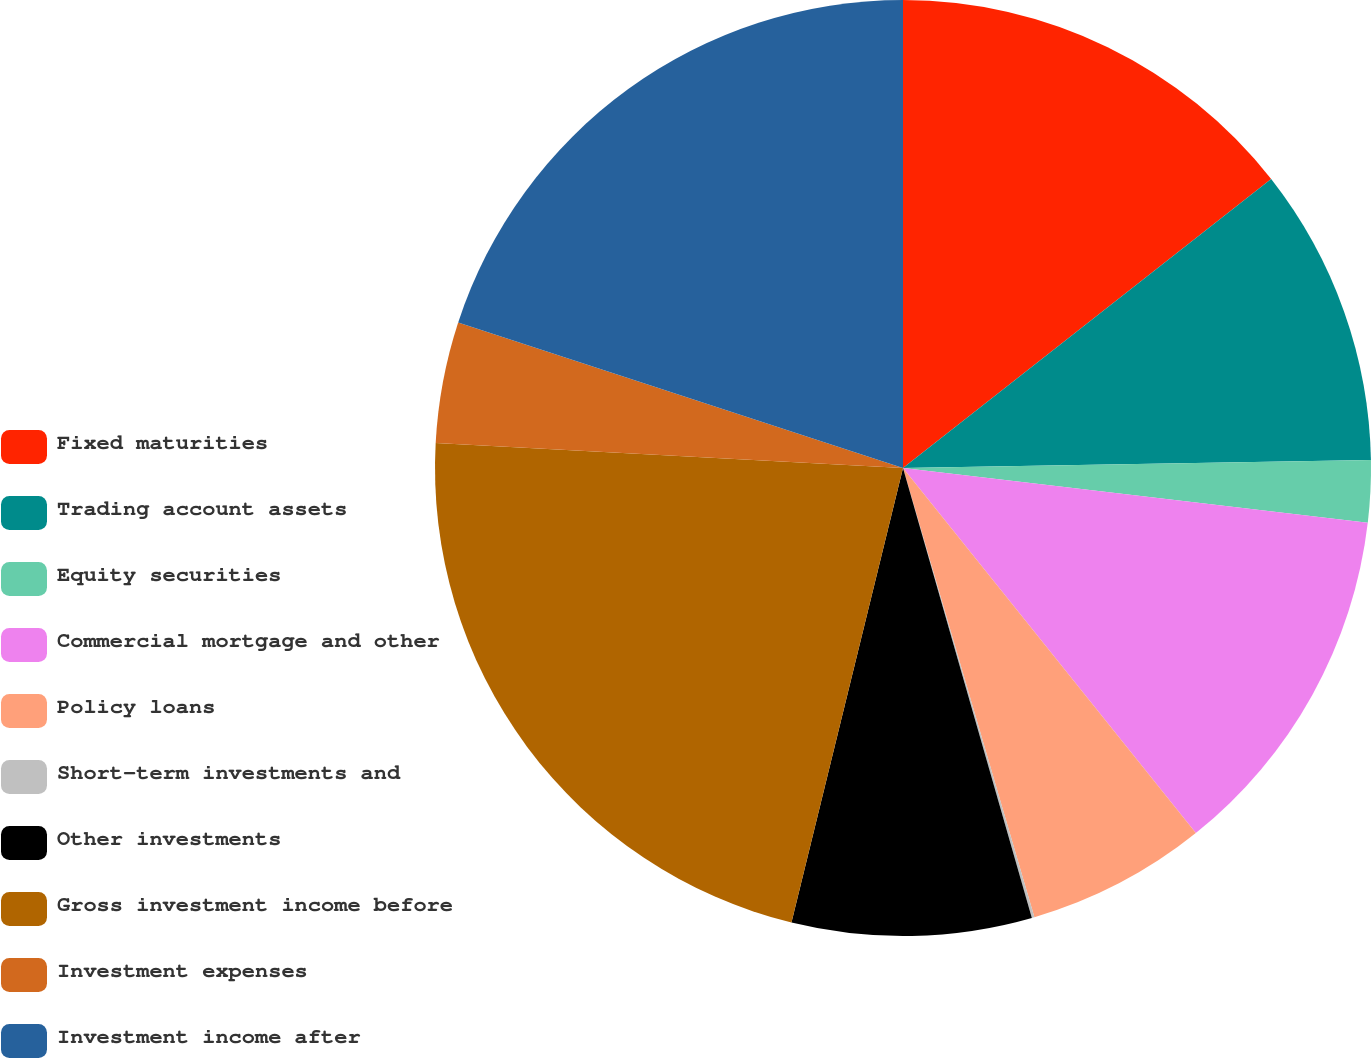Convert chart. <chart><loc_0><loc_0><loc_500><loc_500><pie_chart><fcel>Fixed maturities<fcel>Trading account assets<fcel>Equity securities<fcel>Commercial mortgage and other<fcel>Policy loans<fcel>Short-term investments and<fcel>Other investments<fcel>Gross investment income before<fcel>Investment expenses<fcel>Investment income after<nl><fcel>14.41%<fcel>10.32%<fcel>2.14%<fcel>12.37%<fcel>6.23%<fcel>0.09%<fcel>8.27%<fcel>22.02%<fcel>4.18%<fcel>19.97%<nl></chart> 